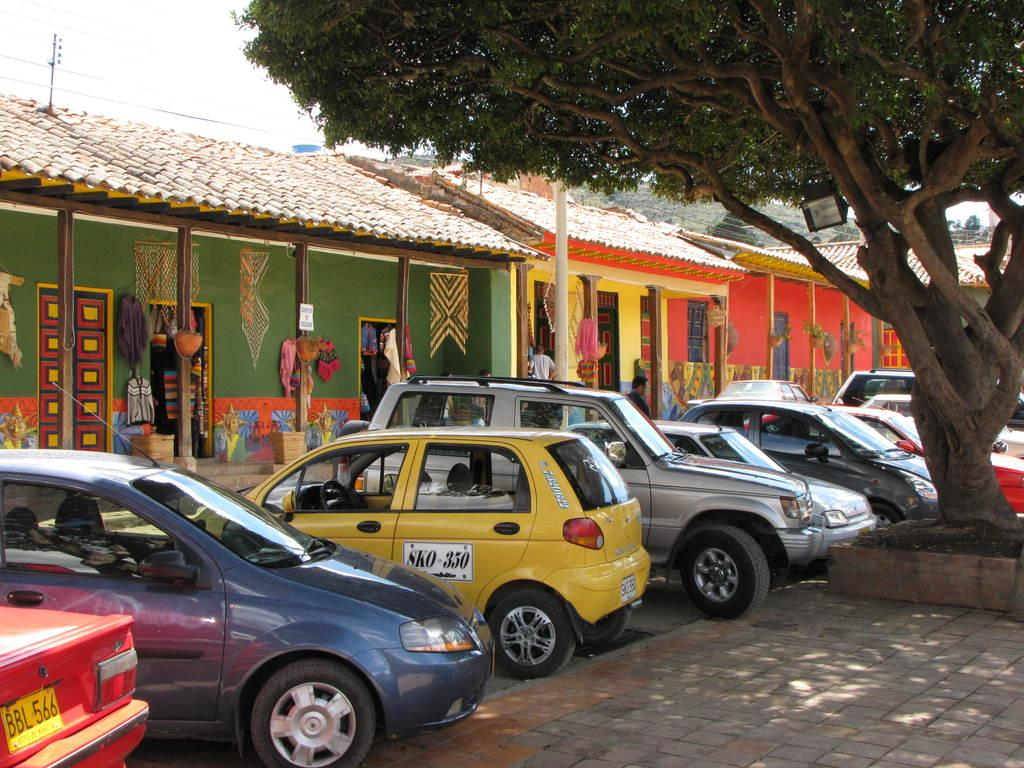<image>
Provide a brief description of the given image. A red car with a yellow licence plate, that reads BBL566 